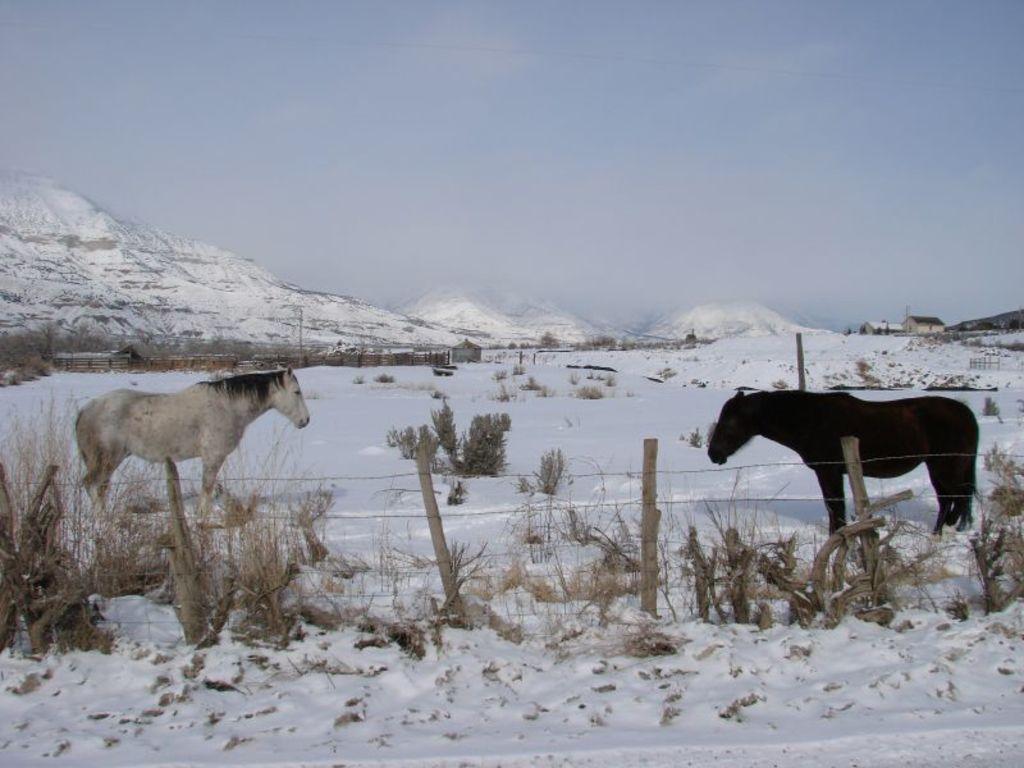Could you give a brief overview of what you see in this image? In this image there are two horses in the center and there is a fence, plants at the bottom there is snow and some grass. And in the background there are some poles, houses, plants and mountains. At the top there is sky. 